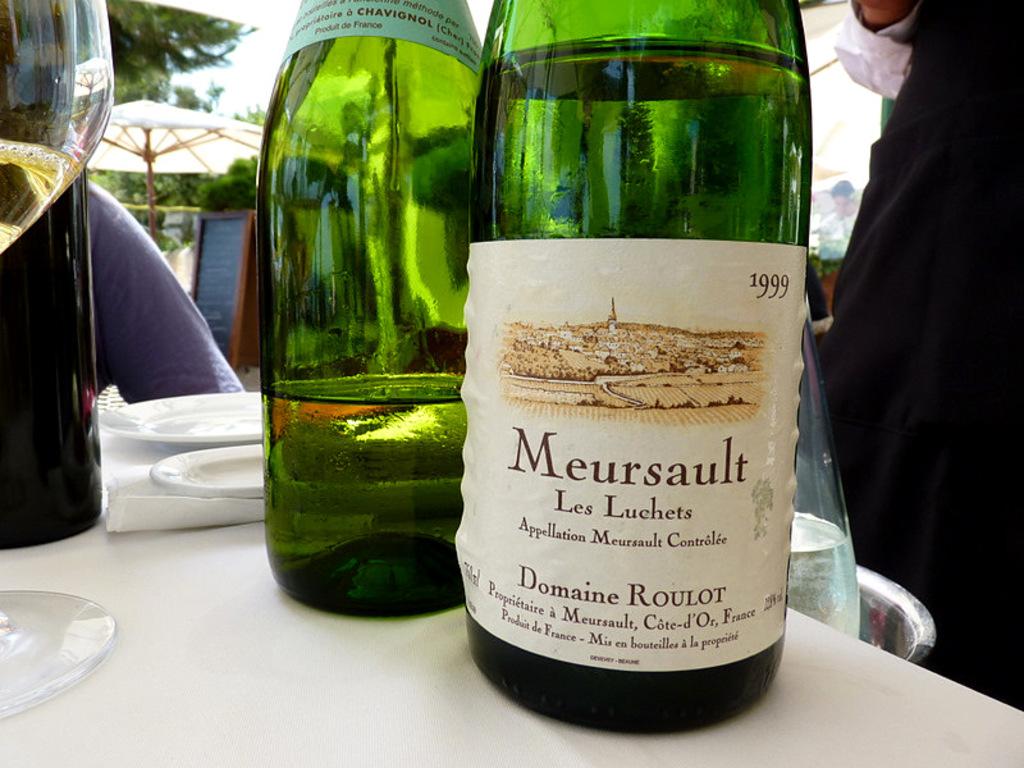What year is on the label?
Make the answer very short. 1999. What is the brand of the first bottle?
Your answer should be very brief. Meursault. 